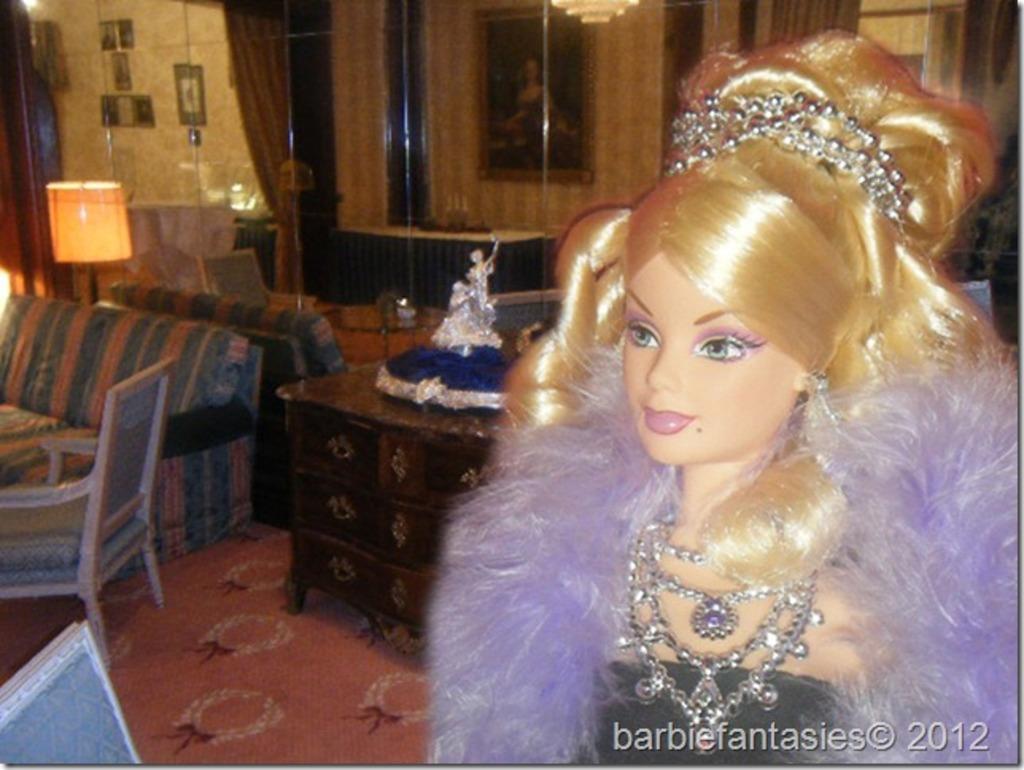How would you summarize this image in a sentence or two? This picture describes about a toy, in the background we can find light sofa and chair. 